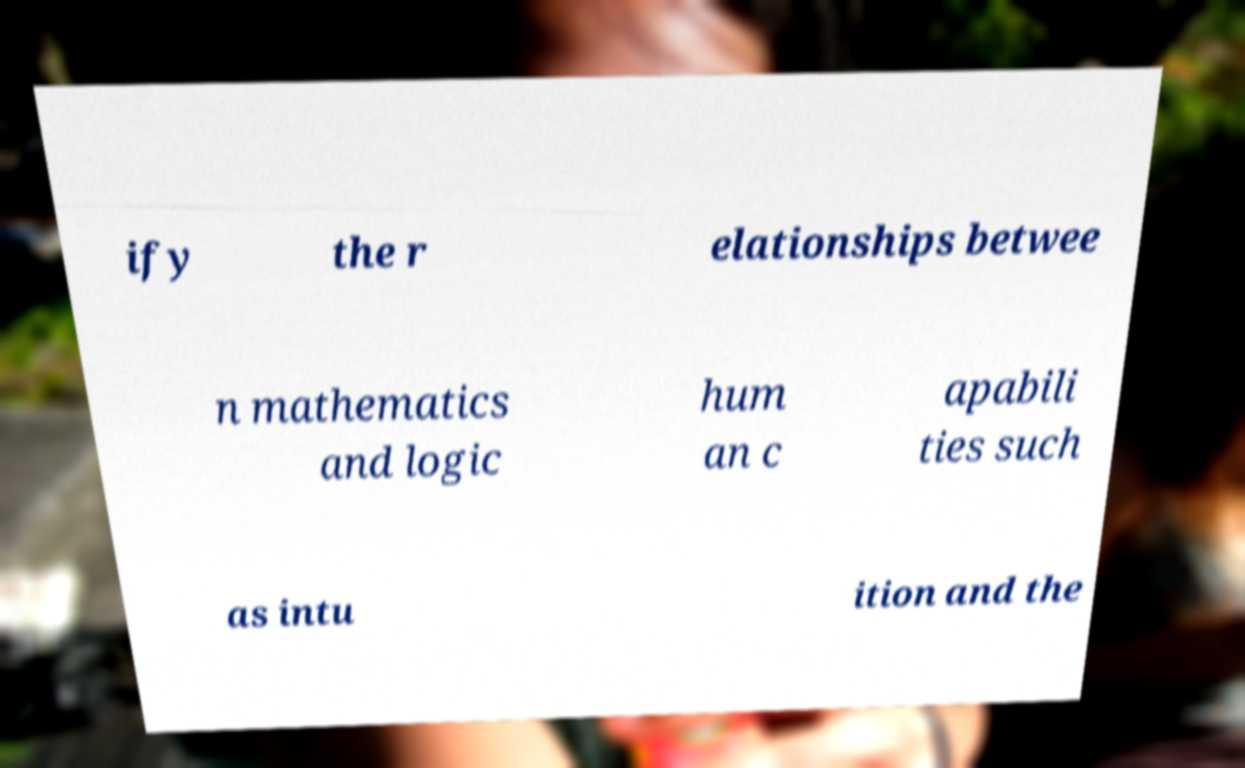Can you accurately transcribe the text from the provided image for me? ify the r elationships betwee n mathematics and logic hum an c apabili ties such as intu ition and the 